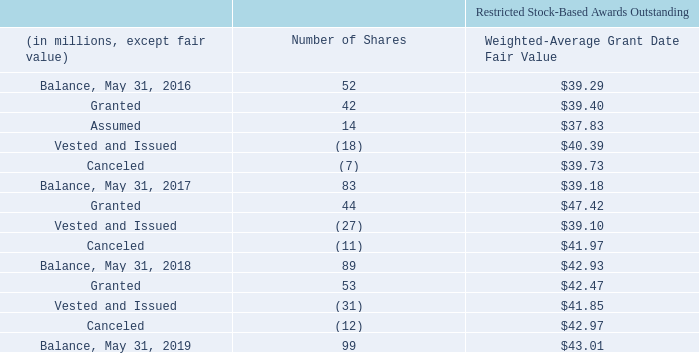The following table summarizes restricted stock-based award activity, including service-based awards and performance-based awards, granted pursuant to Oracle-based stock plans and stock plans assumed from our acquisitions for our last three fiscal years ended May 31, 2019 :
The total grant date fair value of restricted stock-based awards that were vested and issued in fiscal 2019, 2018 and 2017 was $1.3 billion, $1.0 billion and $715 million, respectively. As of May 31, 2019, total unrecognized stock-based compensation expense related to non-vested restricted stock-based awards was $2.8 billion and is expected to be recognized over the remaining weighted-average vesting period of 2.68 years.
No PSUs were granted in each of fiscal 2019 and 2018. In fiscal 2017, 1.7 million PSUs were granted which vest upon the attainment of certain performance metrics and service-based vesting. Based upon actual attainment relative to the “target” performance metric, certain participants have the ability to be issued up to 150% of the target number of PSUs originally granted, or to be issued no PSUs at all. In fiscal 2019, 2.4 million PSUs vested and 1.3 million PSUs remained outstanding as of May 31, 2019.
How many PSUs were granted in fiscal 2019? No psus were granted in each of fiscal 2019 and 2018. How many PSUs remained outstanding as of May 31, 2019? In fiscal 2019, 2.4 million psus vested and 1.3 million psus remained outstanding as of may 31, 2019. When does the company's fiscal year end? May 31. How many shares were granted over the 3 year period from 2017 to 2019 ?
Answer scale should be: million. (42+44+53)
Answer: 139. What is the average total grant date fair value of restricted stock-based awards that were vested and issued in fiscal 2019, 2018 and 2017, in millions?
Answer scale should be: million. (($1.3 billion +$1.0 billion +$715 million)/3)
Answer: 1005. What is the total grant date fair value of restricted stock-based awards that were granted in fiscal 2019?
Answer scale should be: million. 53*42.47
Answer: 2250.91. 